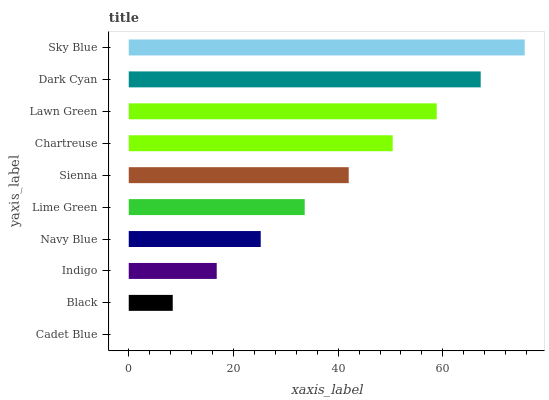Is Cadet Blue the minimum?
Answer yes or no. Yes. Is Sky Blue the maximum?
Answer yes or no. Yes. Is Black the minimum?
Answer yes or no. No. Is Black the maximum?
Answer yes or no. No. Is Black greater than Cadet Blue?
Answer yes or no. Yes. Is Cadet Blue less than Black?
Answer yes or no. Yes. Is Cadet Blue greater than Black?
Answer yes or no. No. Is Black less than Cadet Blue?
Answer yes or no. No. Is Sienna the high median?
Answer yes or no. Yes. Is Lime Green the low median?
Answer yes or no. Yes. Is Sky Blue the high median?
Answer yes or no. No. Is Dark Cyan the low median?
Answer yes or no. No. 